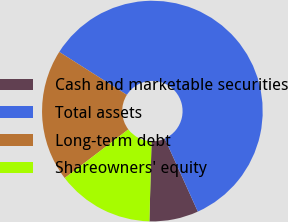Convert chart to OTSL. <chart><loc_0><loc_0><loc_500><loc_500><pie_chart><fcel>Cash and marketable securities<fcel>Total assets<fcel>Long-term debt<fcel>Shareowners' equity<nl><fcel>7.19%<fcel>59.23%<fcel>19.39%<fcel>14.19%<nl></chart> 